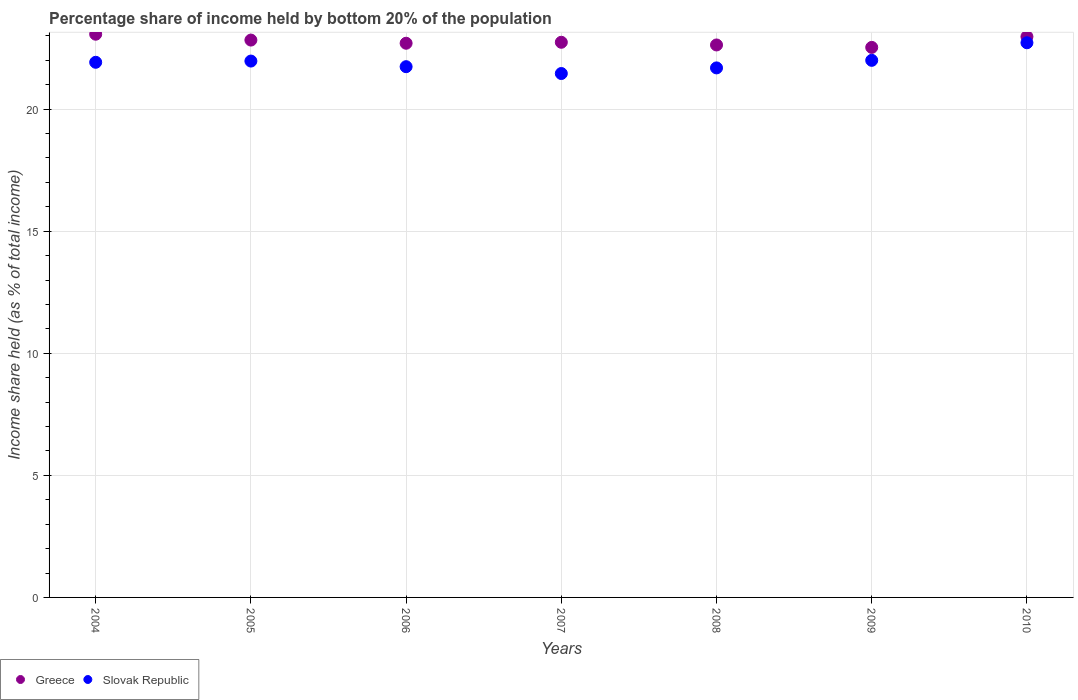How many different coloured dotlines are there?
Your answer should be compact. 2. What is the share of income held by bottom 20% of the population in Greece in 2005?
Provide a succinct answer. 22.83. Across all years, what is the maximum share of income held by bottom 20% of the population in Greece?
Provide a short and direct response. 23.07. Across all years, what is the minimum share of income held by bottom 20% of the population in Slovak Republic?
Provide a short and direct response. 21.46. In which year was the share of income held by bottom 20% of the population in Greece minimum?
Give a very brief answer. 2009. What is the total share of income held by bottom 20% of the population in Greece in the graph?
Give a very brief answer. 159.47. What is the difference between the share of income held by bottom 20% of the population in Slovak Republic in 2007 and that in 2009?
Ensure brevity in your answer.  -0.54. What is the difference between the share of income held by bottom 20% of the population in Greece in 2006 and the share of income held by bottom 20% of the population in Slovak Republic in 2007?
Your answer should be very brief. 1.24. What is the average share of income held by bottom 20% of the population in Greece per year?
Your answer should be very brief. 22.78. In the year 2004, what is the difference between the share of income held by bottom 20% of the population in Slovak Republic and share of income held by bottom 20% of the population in Greece?
Ensure brevity in your answer.  -1.15. In how many years, is the share of income held by bottom 20% of the population in Greece greater than 10 %?
Your response must be concise. 7. What is the ratio of the share of income held by bottom 20% of the population in Slovak Republic in 2005 to that in 2008?
Keep it short and to the point. 1.01. What is the difference between the highest and the second highest share of income held by bottom 20% of the population in Greece?
Keep it short and to the point. 0.1. What is the difference between the highest and the lowest share of income held by bottom 20% of the population in Greece?
Ensure brevity in your answer.  0.54. Is the sum of the share of income held by bottom 20% of the population in Greece in 2007 and 2008 greater than the maximum share of income held by bottom 20% of the population in Slovak Republic across all years?
Offer a very short reply. Yes. Does the share of income held by bottom 20% of the population in Greece monotonically increase over the years?
Provide a short and direct response. No. Is the share of income held by bottom 20% of the population in Slovak Republic strictly less than the share of income held by bottom 20% of the population in Greece over the years?
Offer a terse response. Yes. How many dotlines are there?
Ensure brevity in your answer.  2. How many years are there in the graph?
Ensure brevity in your answer.  7. What is the difference between two consecutive major ticks on the Y-axis?
Give a very brief answer. 5. Are the values on the major ticks of Y-axis written in scientific E-notation?
Provide a short and direct response. No. Does the graph contain grids?
Your answer should be very brief. Yes. Where does the legend appear in the graph?
Give a very brief answer. Bottom left. How are the legend labels stacked?
Make the answer very short. Horizontal. What is the title of the graph?
Ensure brevity in your answer.  Percentage share of income held by bottom 20% of the population. Does "Brazil" appear as one of the legend labels in the graph?
Your answer should be very brief. No. What is the label or title of the X-axis?
Offer a terse response. Years. What is the label or title of the Y-axis?
Ensure brevity in your answer.  Income share held (as % of total income). What is the Income share held (as % of total income) in Greece in 2004?
Your response must be concise. 23.07. What is the Income share held (as % of total income) in Slovak Republic in 2004?
Offer a very short reply. 21.92. What is the Income share held (as % of total income) of Greece in 2005?
Provide a short and direct response. 22.83. What is the Income share held (as % of total income) of Slovak Republic in 2005?
Your answer should be compact. 21.97. What is the Income share held (as % of total income) of Greece in 2006?
Ensure brevity in your answer.  22.7. What is the Income share held (as % of total income) of Slovak Republic in 2006?
Keep it short and to the point. 21.74. What is the Income share held (as % of total income) of Greece in 2007?
Offer a very short reply. 22.74. What is the Income share held (as % of total income) in Slovak Republic in 2007?
Provide a short and direct response. 21.46. What is the Income share held (as % of total income) in Greece in 2008?
Provide a short and direct response. 22.63. What is the Income share held (as % of total income) of Slovak Republic in 2008?
Offer a very short reply. 21.69. What is the Income share held (as % of total income) of Greece in 2009?
Your response must be concise. 22.53. What is the Income share held (as % of total income) of Slovak Republic in 2009?
Keep it short and to the point. 22. What is the Income share held (as % of total income) of Greece in 2010?
Ensure brevity in your answer.  22.97. What is the Income share held (as % of total income) of Slovak Republic in 2010?
Your answer should be compact. 22.72. Across all years, what is the maximum Income share held (as % of total income) in Greece?
Keep it short and to the point. 23.07. Across all years, what is the maximum Income share held (as % of total income) in Slovak Republic?
Ensure brevity in your answer.  22.72. Across all years, what is the minimum Income share held (as % of total income) of Greece?
Give a very brief answer. 22.53. Across all years, what is the minimum Income share held (as % of total income) of Slovak Republic?
Keep it short and to the point. 21.46. What is the total Income share held (as % of total income) in Greece in the graph?
Give a very brief answer. 159.47. What is the total Income share held (as % of total income) in Slovak Republic in the graph?
Your response must be concise. 153.5. What is the difference between the Income share held (as % of total income) of Greece in 2004 and that in 2005?
Give a very brief answer. 0.24. What is the difference between the Income share held (as % of total income) of Slovak Republic in 2004 and that in 2005?
Your answer should be compact. -0.05. What is the difference between the Income share held (as % of total income) in Greece in 2004 and that in 2006?
Offer a very short reply. 0.37. What is the difference between the Income share held (as % of total income) in Slovak Republic in 2004 and that in 2006?
Offer a terse response. 0.18. What is the difference between the Income share held (as % of total income) of Greece in 2004 and that in 2007?
Give a very brief answer. 0.33. What is the difference between the Income share held (as % of total income) in Slovak Republic in 2004 and that in 2007?
Your response must be concise. 0.46. What is the difference between the Income share held (as % of total income) in Greece in 2004 and that in 2008?
Offer a very short reply. 0.44. What is the difference between the Income share held (as % of total income) of Slovak Republic in 2004 and that in 2008?
Make the answer very short. 0.23. What is the difference between the Income share held (as % of total income) in Greece in 2004 and that in 2009?
Ensure brevity in your answer.  0.54. What is the difference between the Income share held (as % of total income) of Slovak Republic in 2004 and that in 2009?
Offer a terse response. -0.08. What is the difference between the Income share held (as % of total income) in Slovak Republic in 2004 and that in 2010?
Provide a succinct answer. -0.8. What is the difference between the Income share held (as % of total income) in Greece in 2005 and that in 2006?
Provide a short and direct response. 0.13. What is the difference between the Income share held (as % of total income) in Slovak Republic in 2005 and that in 2006?
Your answer should be very brief. 0.23. What is the difference between the Income share held (as % of total income) of Greece in 2005 and that in 2007?
Offer a terse response. 0.09. What is the difference between the Income share held (as % of total income) in Slovak Republic in 2005 and that in 2007?
Provide a short and direct response. 0.51. What is the difference between the Income share held (as % of total income) of Slovak Republic in 2005 and that in 2008?
Your response must be concise. 0.28. What is the difference between the Income share held (as % of total income) of Greece in 2005 and that in 2009?
Make the answer very short. 0.3. What is the difference between the Income share held (as % of total income) of Slovak Republic in 2005 and that in 2009?
Your answer should be very brief. -0.03. What is the difference between the Income share held (as % of total income) in Greece in 2005 and that in 2010?
Provide a short and direct response. -0.14. What is the difference between the Income share held (as % of total income) in Slovak Republic in 2005 and that in 2010?
Ensure brevity in your answer.  -0.75. What is the difference between the Income share held (as % of total income) in Greece in 2006 and that in 2007?
Your response must be concise. -0.04. What is the difference between the Income share held (as % of total income) in Slovak Republic in 2006 and that in 2007?
Make the answer very short. 0.28. What is the difference between the Income share held (as % of total income) of Greece in 2006 and that in 2008?
Ensure brevity in your answer.  0.07. What is the difference between the Income share held (as % of total income) in Slovak Republic in 2006 and that in 2008?
Make the answer very short. 0.05. What is the difference between the Income share held (as % of total income) in Greece in 2006 and that in 2009?
Offer a very short reply. 0.17. What is the difference between the Income share held (as % of total income) in Slovak Republic in 2006 and that in 2009?
Offer a terse response. -0.26. What is the difference between the Income share held (as % of total income) of Greece in 2006 and that in 2010?
Offer a very short reply. -0.27. What is the difference between the Income share held (as % of total income) of Slovak Republic in 2006 and that in 2010?
Provide a succinct answer. -0.98. What is the difference between the Income share held (as % of total income) in Greece in 2007 and that in 2008?
Offer a terse response. 0.11. What is the difference between the Income share held (as % of total income) of Slovak Republic in 2007 and that in 2008?
Your answer should be compact. -0.23. What is the difference between the Income share held (as % of total income) of Greece in 2007 and that in 2009?
Offer a terse response. 0.21. What is the difference between the Income share held (as % of total income) in Slovak Republic in 2007 and that in 2009?
Your response must be concise. -0.54. What is the difference between the Income share held (as % of total income) in Greece in 2007 and that in 2010?
Offer a very short reply. -0.23. What is the difference between the Income share held (as % of total income) in Slovak Republic in 2007 and that in 2010?
Provide a short and direct response. -1.26. What is the difference between the Income share held (as % of total income) of Greece in 2008 and that in 2009?
Provide a short and direct response. 0.1. What is the difference between the Income share held (as % of total income) in Slovak Republic in 2008 and that in 2009?
Keep it short and to the point. -0.31. What is the difference between the Income share held (as % of total income) in Greece in 2008 and that in 2010?
Your response must be concise. -0.34. What is the difference between the Income share held (as % of total income) of Slovak Republic in 2008 and that in 2010?
Make the answer very short. -1.03. What is the difference between the Income share held (as % of total income) of Greece in 2009 and that in 2010?
Make the answer very short. -0.44. What is the difference between the Income share held (as % of total income) in Slovak Republic in 2009 and that in 2010?
Your response must be concise. -0.72. What is the difference between the Income share held (as % of total income) of Greece in 2004 and the Income share held (as % of total income) of Slovak Republic in 2005?
Provide a short and direct response. 1.1. What is the difference between the Income share held (as % of total income) in Greece in 2004 and the Income share held (as % of total income) in Slovak Republic in 2006?
Make the answer very short. 1.33. What is the difference between the Income share held (as % of total income) of Greece in 2004 and the Income share held (as % of total income) of Slovak Republic in 2007?
Your answer should be very brief. 1.61. What is the difference between the Income share held (as % of total income) in Greece in 2004 and the Income share held (as % of total income) in Slovak Republic in 2008?
Make the answer very short. 1.38. What is the difference between the Income share held (as % of total income) of Greece in 2004 and the Income share held (as % of total income) of Slovak Republic in 2009?
Ensure brevity in your answer.  1.07. What is the difference between the Income share held (as % of total income) in Greece in 2004 and the Income share held (as % of total income) in Slovak Republic in 2010?
Your answer should be compact. 0.35. What is the difference between the Income share held (as % of total income) in Greece in 2005 and the Income share held (as % of total income) in Slovak Republic in 2006?
Provide a short and direct response. 1.09. What is the difference between the Income share held (as % of total income) of Greece in 2005 and the Income share held (as % of total income) of Slovak Republic in 2007?
Provide a short and direct response. 1.37. What is the difference between the Income share held (as % of total income) of Greece in 2005 and the Income share held (as % of total income) of Slovak Republic in 2008?
Provide a short and direct response. 1.14. What is the difference between the Income share held (as % of total income) in Greece in 2005 and the Income share held (as % of total income) in Slovak Republic in 2009?
Your response must be concise. 0.83. What is the difference between the Income share held (as % of total income) in Greece in 2005 and the Income share held (as % of total income) in Slovak Republic in 2010?
Ensure brevity in your answer.  0.11. What is the difference between the Income share held (as % of total income) of Greece in 2006 and the Income share held (as % of total income) of Slovak Republic in 2007?
Your answer should be very brief. 1.24. What is the difference between the Income share held (as % of total income) in Greece in 2006 and the Income share held (as % of total income) in Slovak Republic in 2009?
Your answer should be compact. 0.7. What is the difference between the Income share held (as % of total income) of Greece in 2006 and the Income share held (as % of total income) of Slovak Republic in 2010?
Provide a short and direct response. -0.02. What is the difference between the Income share held (as % of total income) of Greece in 2007 and the Income share held (as % of total income) of Slovak Republic in 2009?
Give a very brief answer. 0.74. What is the difference between the Income share held (as % of total income) of Greece in 2008 and the Income share held (as % of total income) of Slovak Republic in 2009?
Give a very brief answer. 0.63. What is the difference between the Income share held (as % of total income) in Greece in 2008 and the Income share held (as % of total income) in Slovak Republic in 2010?
Ensure brevity in your answer.  -0.09. What is the difference between the Income share held (as % of total income) in Greece in 2009 and the Income share held (as % of total income) in Slovak Republic in 2010?
Offer a very short reply. -0.19. What is the average Income share held (as % of total income) in Greece per year?
Make the answer very short. 22.78. What is the average Income share held (as % of total income) of Slovak Republic per year?
Your answer should be very brief. 21.93. In the year 2004, what is the difference between the Income share held (as % of total income) in Greece and Income share held (as % of total income) in Slovak Republic?
Offer a terse response. 1.15. In the year 2005, what is the difference between the Income share held (as % of total income) of Greece and Income share held (as % of total income) of Slovak Republic?
Provide a short and direct response. 0.86. In the year 2006, what is the difference between the Income share held (as % of total income) in Greece and Income share held (as % of total income) in Slovak Republic?
Your answer should be very brief. 0.96. In the year 2007, what is the difference between the Income share held (as % of total income) in Greece and Income share held (as % of total income) in Slovak Republic?
Your response must be concise. 1.28. In the year 2009, what is the difference between the Income share held (as % of total income) of Greece and Income share held (as % of total income) of Slovak Republic?
Your answer should be very brief. 0.53. In the year 2010, what is the difference between the Income share held (as % of total income) of Greece and Income share held (as % of total income) of Slovak Republic?
Your answer should be very brief. 0.25. What is the ratio of the Income share held (as % of total income) in Greece in 2004 to that in 2005?
Your answer should be very brief. 1.01. What is the ratio of the Income share held (as % of total income) of Slovak Republic in 2004 to that in 2005?
Provide a succinct answer. 1. What is the ratio of the Income share held (as % of total income) of Greece in 2004 to that in 2006?
Keep it short and to the point. 1.02. What is the ratio of the Income share held (as % of total income) of Slovak Republic in 2004 to that in 2006?
Give a very brief answer. 1.01. What is the ratio of the Income share held (as % of total income) of Greece in 2004 to that in 2007?
Your answer should be very brief. 1.01. What is the ratio of the Income share held (as % of total income) in Slovak Republic in 2004 to that in 2007?
Give a very brief answer. 1.02. What is the ratio of the Income share held (as % of total income) in Greece in 2004 to that in 2008?
Ensure brevity in your answer.  1.02. What is the ratio of the Income share held (as % of total income) of Slovak Republic in 2004 to that in 2008?
Your response must be concise. 1.01. What is the ratio of the Income share held (as % of total income) of Slovak Republic in 2004 to that in 2009?
Ensure brevity in your answer.  1. What is the ratio of the Income share held (as % of total income) in Greece in 2004 to that in 2010?
Give a very brief answer. 1. What is the ratio of the Income share held (as % of total income) in Slovak Republic in 2004 to that in 2010?
Your answer should be compact. 0.96. What is the ratio of the Income share held (as % of total income) in Slovak Republic in 2005 to that in 2006?
Provide a short and direct response. 1.01. What is the ratio of the Income share held (as % of total income) in Slovak Republic in 2005 to that in 2007?
Provide a succinct answer. 1.02. What is the ratio of the Income share held (as % of total income) in Greece in 2005 to that in 2008?
Give a very brief answer. 1.01. What is the ratio of the Income share held (as % of total income) in Slovak Republic in 2005 to that in 2008?
Provide a succinct answer. 1.01. What is the ratio of the Income share held (as % of total income) of Greece in 2005 to that in 2009?
Keep it short and to the point. 1.01. What is the ratio of the Income share held (as % of total income) in Greece in 2006 to that in 2007?
Offer a terse response. 1. What is the ratio of the Income share held (as % of total income) in Greece in 2006 to that in 2009?
Your response must be concise. 1.01. What is the ratio of the Income share held (as % of total income) in Slovak Republic in 2006 to that in 2009?
Your answer should be compact. 0.99. What is the ratio of the Income share held (as % of total income) of Slovak Republic in 2006 to that in 2010?
Offer a terse response. 0.96. What is the ratio of the Income share held (as % of total income) of Greece in 2007 to that in 2008?
Provide a succinct answer. 1. What is the ratio of the Income share held (as % of total income) of Greece in 2007 to that in 2009?
Offer a terse response. 1.01. What is the ratio of the Income share held (as % of total income) in Slovak Republic in 2007 to that in 2009?
Keep it short and to the point. 0.98. What is the ratio of the Income share held (as % of total income) of Slovak Republic in 2007 to that in 2010?
Make the answer very short. 0.94. What is the ratio of the Income share held (as % of total income) of Slovak Republic in 2008 to that in 2009?
Your response must be concise. 0.99. What is the ratio of the Income share held (as % of total income) in Greece in 2008 to that in 2010?
Your response must be concise. 0.99. What is the ratio of the Income share held (as % of total income) in Slovak Republic in 2008 to that in 2010?
Keep it short and to the point. 0.95. What is the ratio of the Income share held (as % of total income) of Greece in 2009 to that in 2010?
Offer a very short reply. 0.98. What is the ratio of the Income share held (as % of total income) in Slovak Republic in 2009 to that in 2010?
Make the answer very short. 0.97. What is the difference between the highest and the second highest Income share held (as % of total income) of Greece?
Keep it short and to the point. 0.1. What is the difference between the highest and the second highest Income share held (as % of total income) of Slovak Republic?
Offer a very short reply. 0.72. What is the difference between the highest and the lowest Income share held (as % of total income) in Greece?
Give a very brief answer. 0.54. What is the difference between the highest and the lowest Income share held (as % of total income) of Slovak Republic?
Provide a short and direct response. 1.26. 